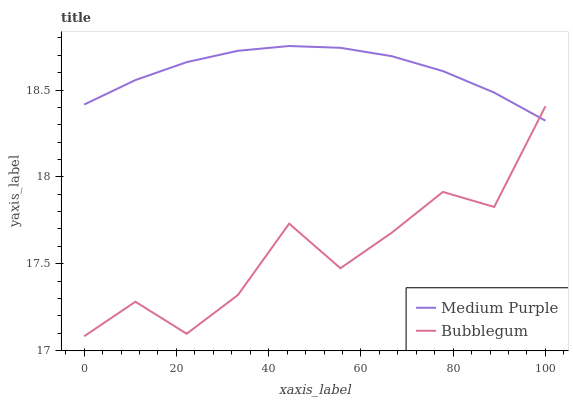Does Bubblegum have the minimum area under the curve?
Answer yes or no. Yes. Does Medium Purple have the maximum area under the curve?
Answer yes or no. Yes. Does Bubblegum have the maximum area under the curve?
Answer yes or no. No. Is Medium Purple the smoothest?
Answer yes or no. Yes. Is Bubblegum the roughest?
Answer yes or no. Yes. Is Bubblegum the smoothest?
Answer yes or no. No. Does Medium Purple have the highest value?
Answer yes or no. Yes. Does Bubblegum have the highest value?
Answer yes or no. No. 